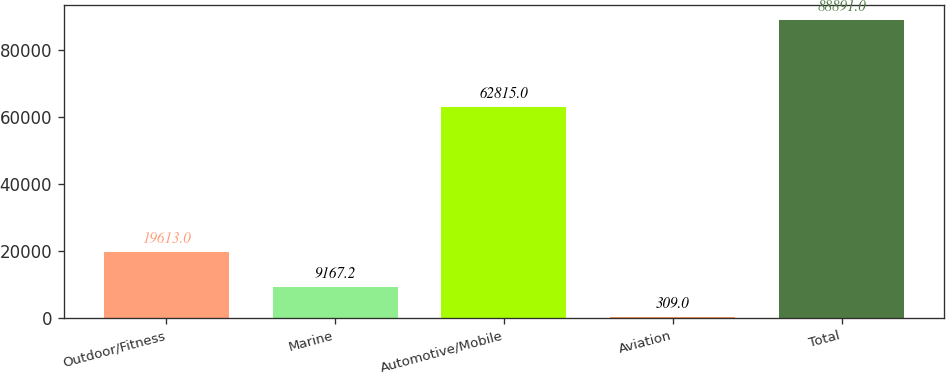Convert chart to OTSL. <chart><loc_0><loc_0><loc_500><loc_500><bar_chart><fcel>Outdoor/Fitness<fcel>Marine<fcel>Automotive/Mobile<fcel>Aviation<fcel>Total<nl><fcel>19613<fcel>9167.2<fcel>62815<fcel>309<fcel>88891<nl></chart> 